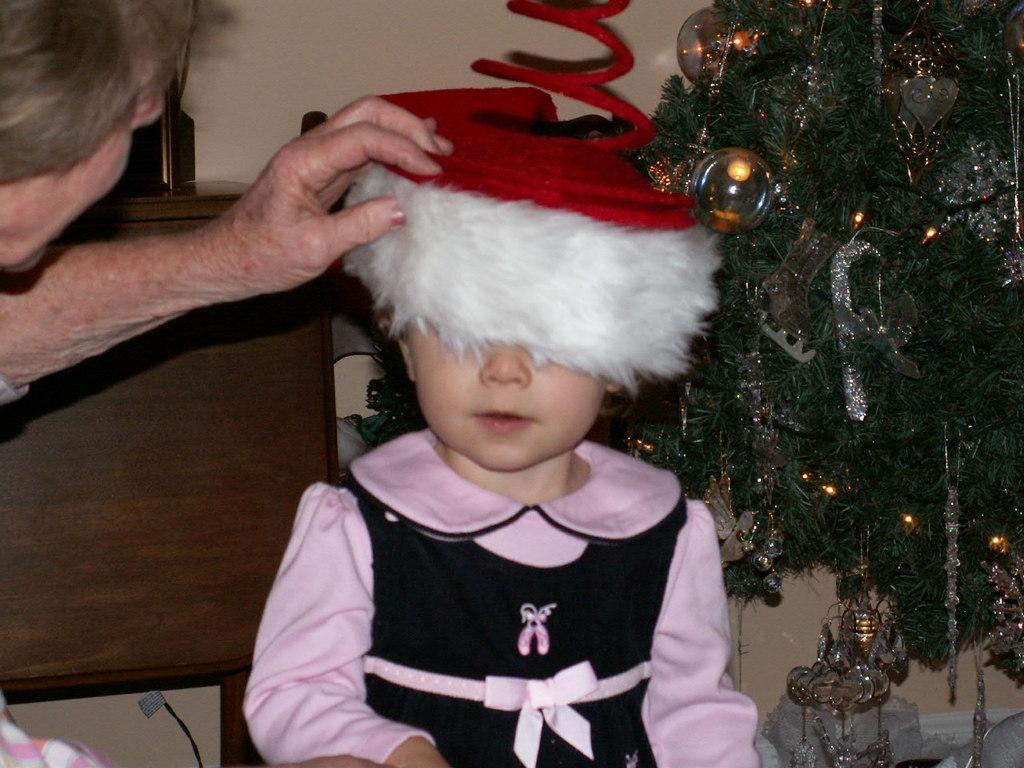Please provide a concise description of this image. In this picture we can see a child. There is a person on the left side. We can see a Christmas tree and decorative items on this tree. This tree is on the right side. There is an object on a wooden desk. A wall is visible in the background. 